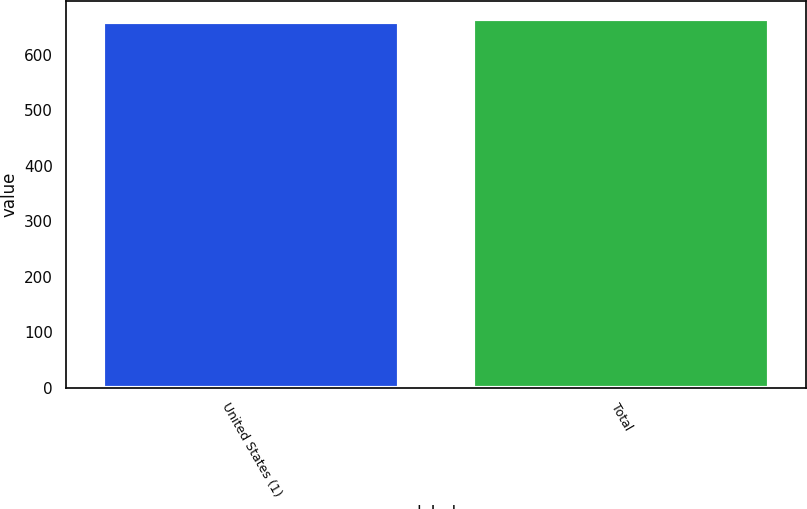Convert chart. <chart><loc_0><loc_0><loc_500><loc_500><bar_chart><fcel>United States (1)<fcel>Total<nl><fcel>658.5<fcel>664.7<nl></chart> 